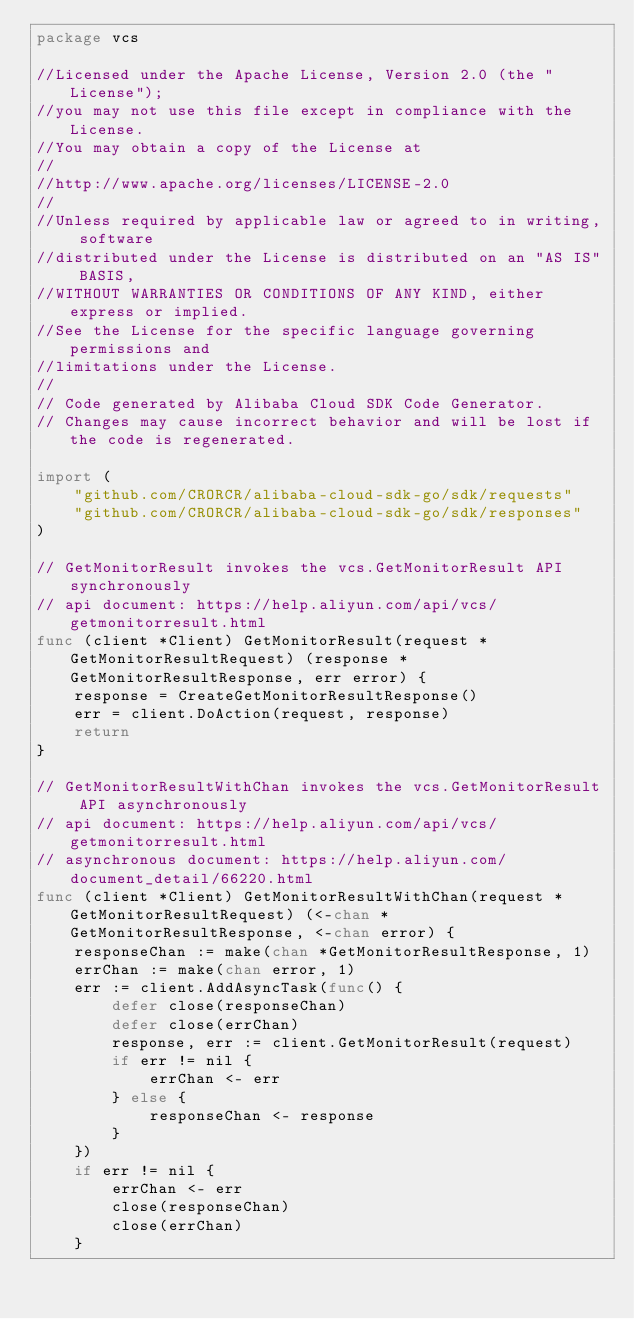Convert code to text. <code><loc_0><loc_0><loc_500><loc_500><_Go_>package vcs

//Licensed under the Apache License, Version 2.0 (the "License");
//you may not use this file except in compliance with the License.
//You may obtain a copy of the License at
//
//http://www.apache.org/licenses/LICENSE-2.0
//
//Unless required by applicable law or agreed to in writing, software
//distributed under the License is distributed on an "AS IS" BASIS,
//WITHOUT WARRANTIES OR CONDITIONS OF ANY KIND, either express or implied.
//See the License for the specific language governing permissions and
//limitations under the License.
//
// Code generated by Alibaba Cloud SDK Code Generator.
// Changes may cause incorrect behavior and will be lost if the code is regenerated.

import (
	"github.com/CRORCR/alibaba-cloud-sdk-go/sdk/requests"
	"github.com/CRORCR/alibaba-cloud-sdk-go/sdk/responses"
)

// GetMonitorResult invokes the vcs.GetMonitorResult API synchronously
// api document: https://help.aliyun.com/api/vcs/getmonitorresult.html
func (client *Client) GetMonitorResult(request *GetMonitorResultRequest) (response *GetMonitorResultResponse, err error) {
	response = CreateGetMonitorResultResponse()
	err = client.DoAction(request, response)
	return
}

// GetMonitorResultWithChan invokes the vcs.GetMonitorResult API asynchronously
// api document: https://help.aliyun.com/api/vcs/getmonitorresult.html
// asynchronous document: https://help.aliyun.com/document_detail/66220.html
func (client *Client) GetMonitorResultWithChan(request *GetMonitorResultRequest) (<-chan *GetMonitorResultResponse, <-chan error) {
	responseChan := make(chan *GetMonitorResultResponse, 1)
	errChan := make(chan error, 1)
	err := client.AddAsyncTask(func() {
		defer close(responseChan)
		defer close(errChan)
		response, err := client.GetMonitorResult(request)
		if err != nil {
			errChan <- err
		} else {
			responseChan <- response
		}
	})
	if err != nil {
		errChan <- err
		close(responseChan)
		close(errChan)
	}</code> 